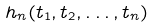<formula> <loc_0><loc_0><loc_500><loc_500>h _ { n } ( t _ { 1 } , t _ { 2 } , \dots , t _ { n } )</formula> 